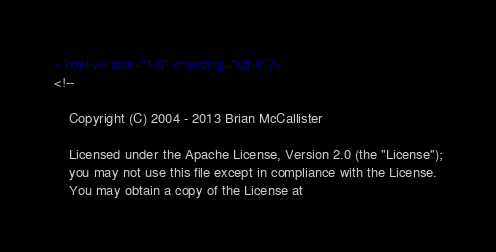<code> <loc_0><loc_0><loc_500><loc_500><_XML_><?xml version="1.0" encoding="utf-8"?>
<!--

    Copyright (C) 2004 - 2013 Brian McCallister

    Licensed under the Apache License, Version 2.0 (the "License");
    you may not use this file except in compliance with the License.
    You may obtain a copy of the License at
</code> 